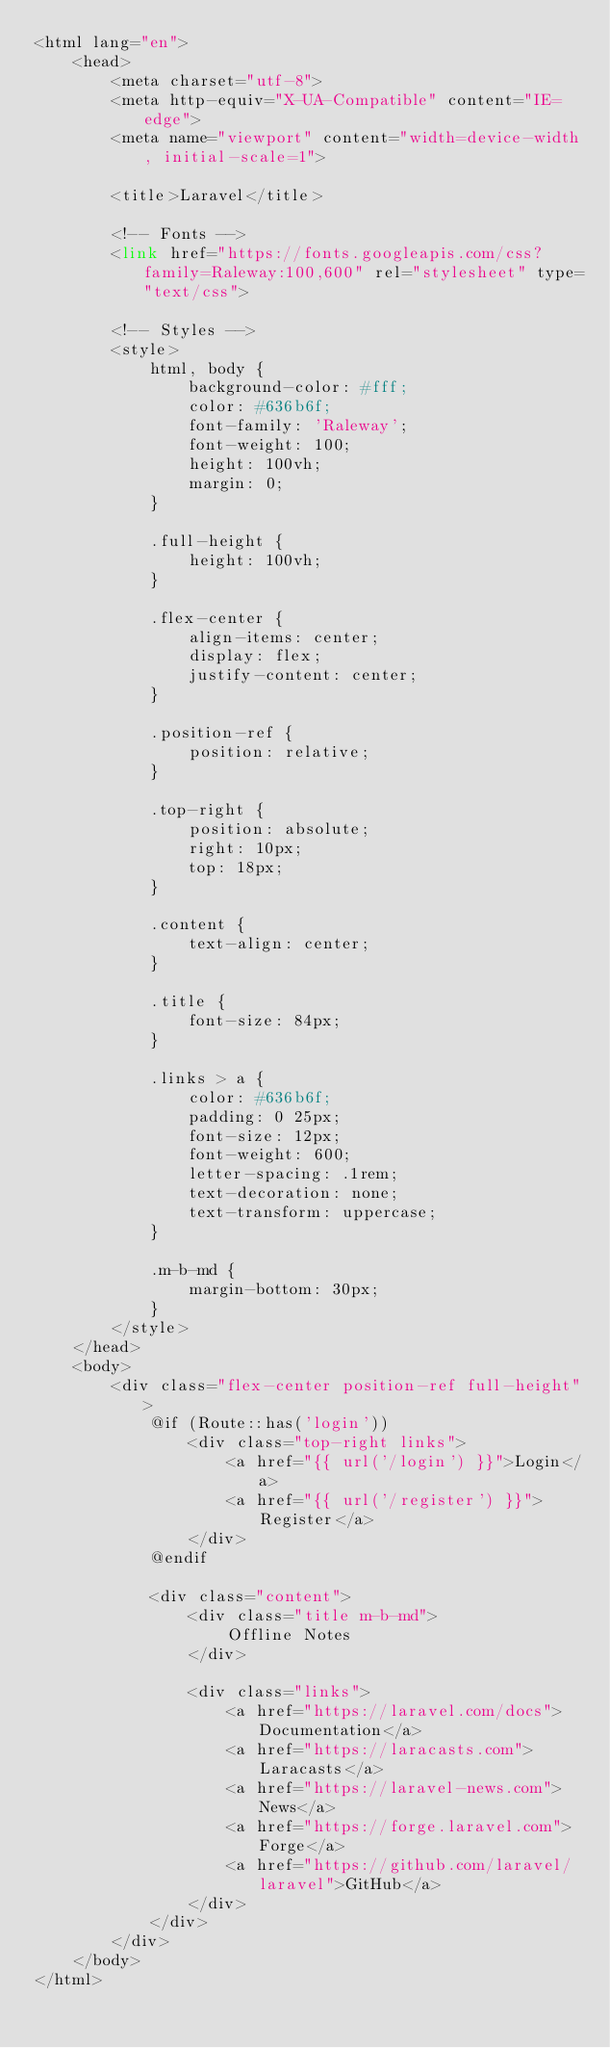<code> <loc_0><loc_0><loc_500><loc_500><_PHP_><html lang="en">
    <head>
        <meta charset="utf-8">
        <meta http-equiv="X-UA-Compatible" content="IE=edge">
        <meta name="viewport" content="width=device-width, initial-scale=1">

        <title>Laravel</title>

        <!-- Fonts -->
        <link href="https://fonts.googleapis.com/css?family=Raleway:100,600" rel="stylesheet" type="text/css">

        <!-- Styles -->
        <style>
            html, body {
                background-color: #fff;
                color: #636b6f;
                font-family: 'Raleway';
                font-weight: 100;
                height: 100vh;
                margin: 0;
            }

            .full-height {
                height: 100vh;
            }

            .flex-center {
                align-items: center;
                display: flex;
                justify-content: center;
            }

            .position-ref {
                position: relative;
            }

            .top-right {
                position: absolute;
                right: 10px;
                top: 18px;
            }

            .content {
                text-align: center;
            }

            .title {
                font-size: 84px;
            }

            .links > a {
                color: #636b6f;
                padding: 0 25px;
                font-size: 12px;
                font-weight: 600;
                letter-spacing: .1rem;
                text-decoration: none;
                text-transform: uppercase;
            }

            .m-b-md {
                margin-bottom: 30px;
            }
        </style>
    </head>
    <body>
        <div class="flex-center position-ref full-height">
            @if (Route::has('login'))
                <div class="top-right links">
                    <a href="{{ url('/login') }}">Login</a>
                    <a href="{{ url('/register') }}">Register</a>
                </div>
            @endif

            <div class="content">
                <div class="title m-b-md">
                    Offline Notes
                </div>

                <div class="links">
                    <a href="https://laravel.com/docs">Documentation</a>
                    <a href="https://laracasts.com">Laracasts</a>
                    <a href="https://laravel-news.com">News</a>
                    <a href="https://forge.laravel.com">Forge</a>
                    <a href="https://github.com/laravel/laravel">GitHub</a>
                </div>
            </div>
        </div>
    </body>
</html>
</code> 